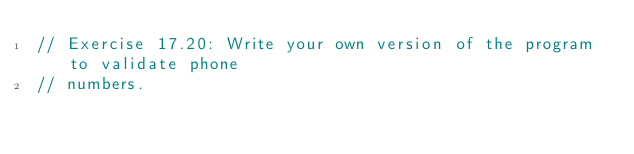<code> <loc_0><loc_0><loc_500><loc_500><_C++_>// Exercise 17.20: Write your own version of the program to validate phone
// numbers.
</code> 